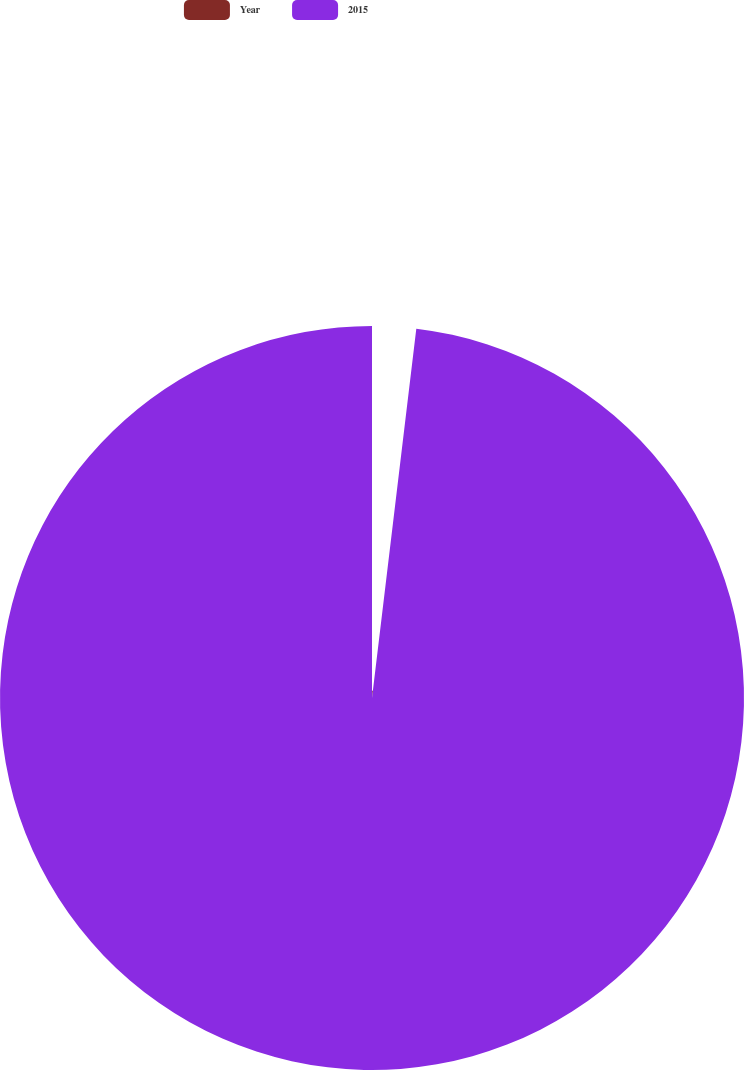<chart> <loc_0><loc_0><loc_500><loc_500><pie_chart><fcel>Year<fcel>2015<nl><fcel>1.9%<fcel>98.1%<nl></chart> 